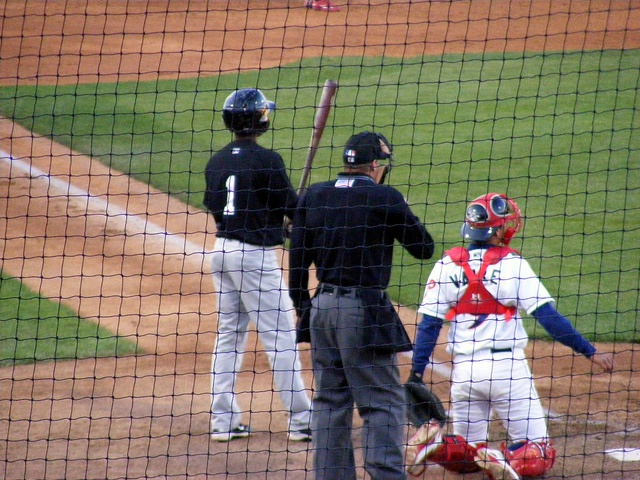Describe the objects in this image and their specific colors. I can see people in brown, lavender, darkgray, and navy tones, people in brown, black, darkgray, and lavender tones, people in brown, black, gray, and darkblue tones, people in brown, maroon, and black tones, and baseball glove in brown, black, gray, and darkblue tones in this image. 